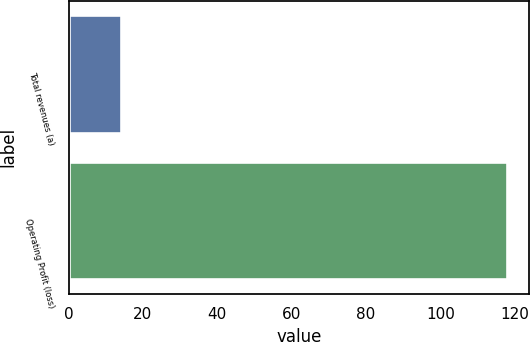Convert chart. <chart><loc_0><loc_0><loc_500><loc_500><bar_chart><fcel>Total revenues (a)<fcel>Operating Profit (loss)<nl><fcel>14<fcel>118<nl></chart> 